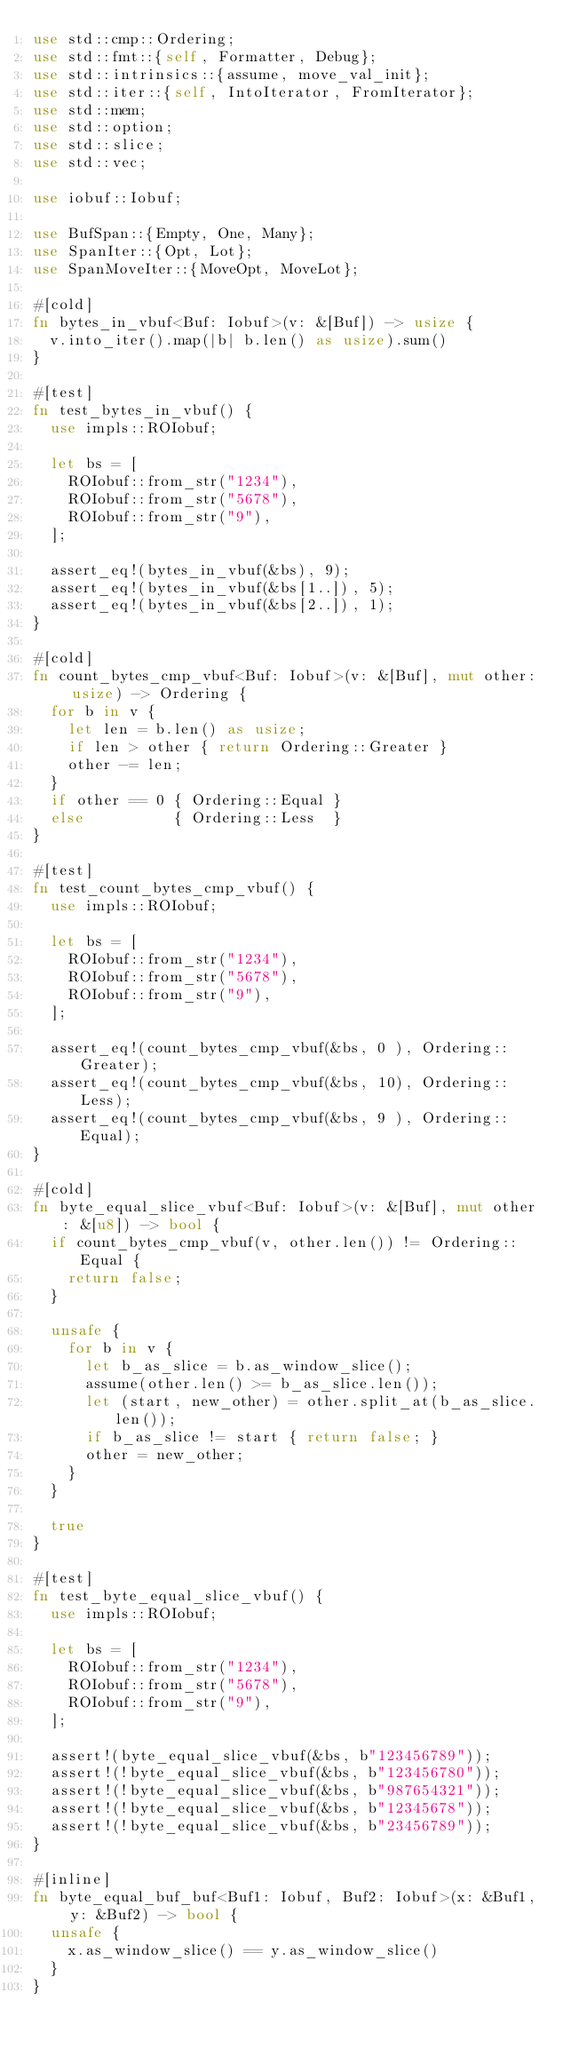<code> <loc_0><loc_0><loc_500><loc_500><_Rust_>use std::cmp::Ordering;
use std::fmt::{self, Formatter, Debug};
use std::intrinsics::{assume, move_val_init};
use std::iter::{self, IntoIterator, FromIterator};
use std::mem;
use std::option;
use std::slice;
use std::vec;

use iobuf::Iobuf;

use BufSpan::{Empty, One, Many};
use SpanIter::{Opt, Lot};
use SpanMoveIter::{MoveOpt, MoveLot};

#[cold]
fn bytes_in_vbuf<Buf: Iobuf>(v: &[Buf]) -> usize {
  v.into_iter().map(|b| b.len() as usize).sum()
}

#[test]
fn test_bytes_in_vbuf() {
  use impls::ROIobuf;

  let bs = [
    ROIobuf::from_str("1234"),
    ROIobuf::from_str("5678"),
    ROIobuf::from_str("9"),
  ];

  assert_eq!(bytes_in_vbuf(&bs), 9);
  assert_eq!(bytes_in_vbuf(&bs[1..]), 5);
  assert_eq!(bytes_in_vbuf(&bs[2..]), 1);
}

#[cold]
fn count_bytes_cmp_vbuf<Buf: Iobuf>(v: &[Buf], mut other: usize) -> Ordering {
  for b in v {
    let len = b.len() as usize;
    if len > other { return Ordering::Greater }
    other -= len;
  }
  if other == 0 { Ordering::Equal }
  else          { Ordering::Less  }
}

#[test]
fn test_count_bytes_cmp_vbuf() {
  use impls::ROIobuf;

  let bs = [
    ROIobuf::from_str("1234"),
    ROIobuf::from_str("5678"),
    ROIobuf::from_str("9"),
  ];

  assert_eq!(count_bytes_cmp_vbuf(&bs, 0 ), Ordering::Greater);
  assert_eq!(count_bytes_cmp_vbuf(&bs, 10), Ordering::Less);
  assert_eq!(count_bytes_cmp_vbuf(&bs, 9 ), Ordering::Equal);
}

#[cold]
fn byte_equal_slice_vbuf<Buf: Iobuf>(v: &[Buf], mut other: &[u8]) -> bool {
  if count_bytes_cmp_vbuf(v, other.len()) != Ordering::Equal {
    return false;
  }

  unsafe {
    for b in v {
      let b_as_slice = b.as_window_slice();
      assume(other.len() >= b_as_slice.len());
      let (start, new_other) = other.split_at(b_as_slice.len());
      if b_as_slice != start { return false; }
      other = new_other;
    }
  }

  true
}

#[test]
fn test_byte_equal_slice_vbuf() {
  use impls::ROIobuf;

  let bs = [
    ROIobuf::from_str("1234"),
    ROIobuf::from_str("5678"),
    ROIobuf::from_str("9"),
  ];

  assert!(byte_equal_slice_vbuf(&bs, b"123456789"));
  assert!(!byte_equal_slice_vbuf(&bs, b"123456780"));
  assert!(!byte_equal_slice_vbuf(&bs, b"987654321"));
  assert!(!byte_equal_slice_vbuf(&bs, b"12345678"));
  assert!(!byte_equal_slice_vbuf(&bs, b"23456789"));
}

#[inline]
fn byte_equal_buf_buf<Buf1: Iobuf, Buf2: Iobuf>(x: &Buf1, y: &Buf2) -> bool {
  unsafe {
    x.as_window_slice() == y.as_window_slice()
  }
}
</code> 